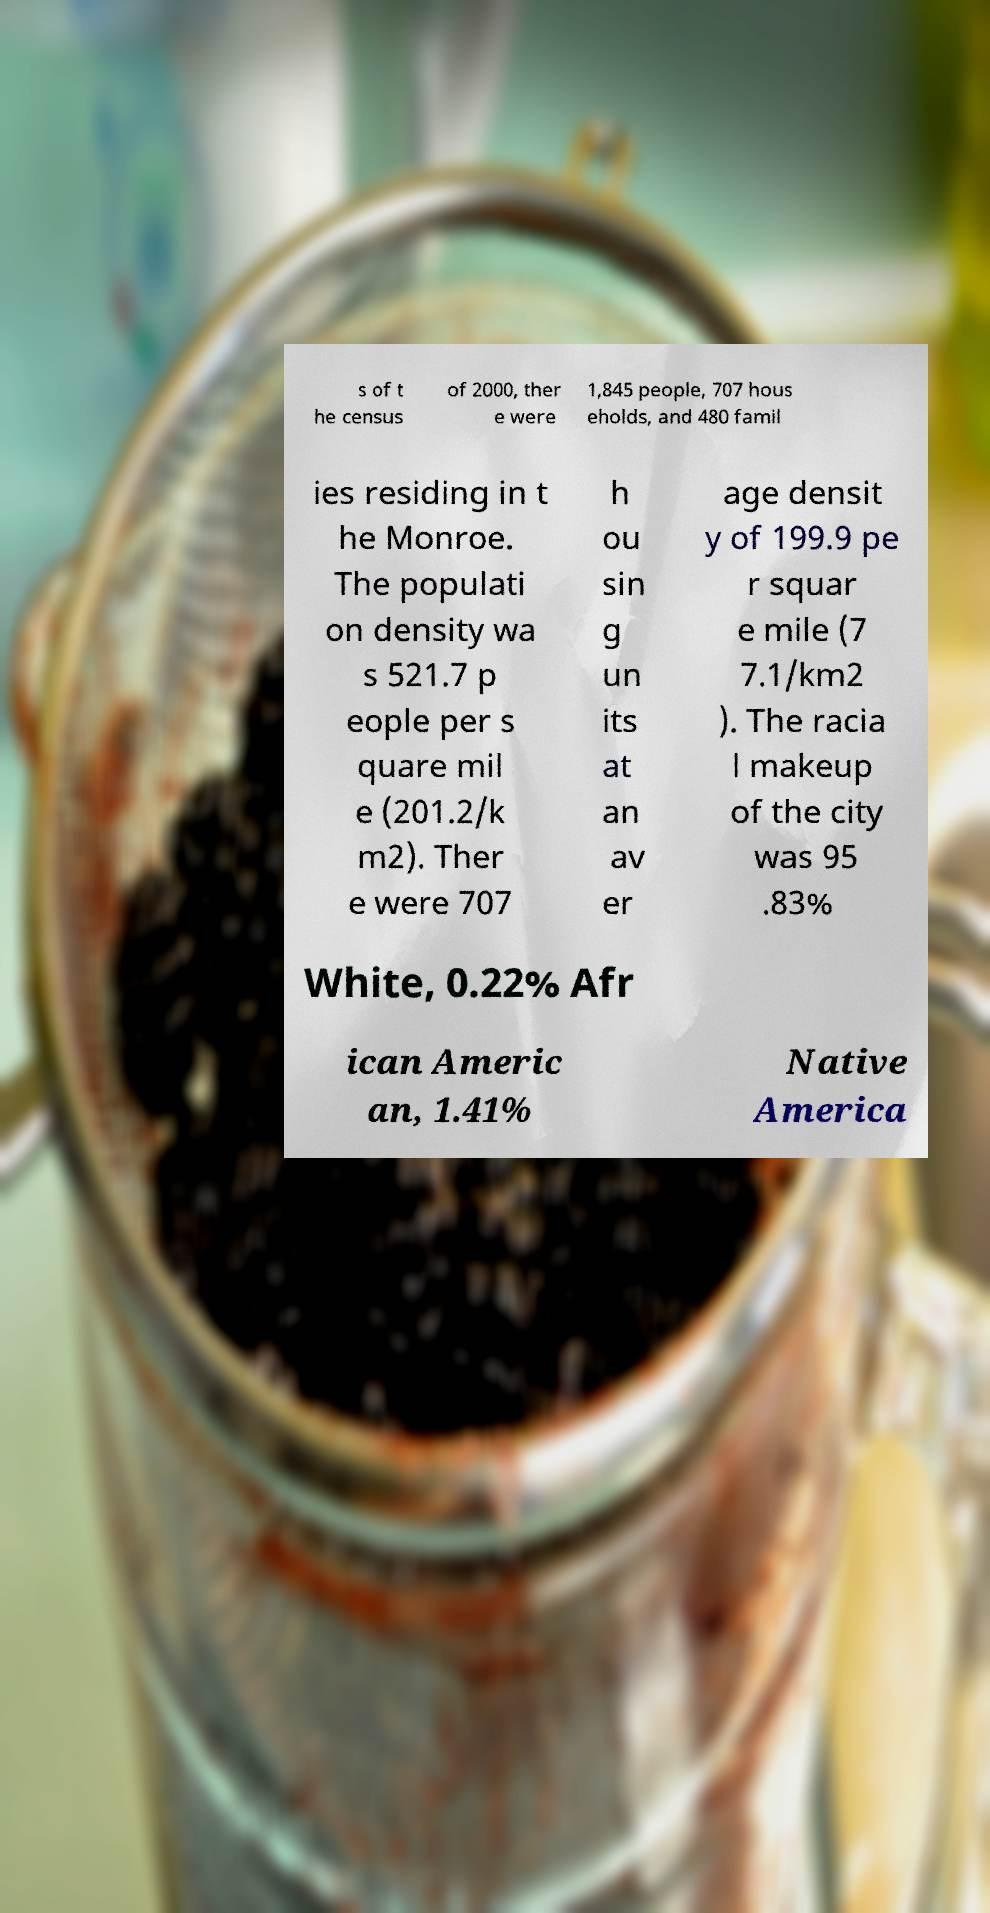For documentation purposes, I need the text within this image transcribed. Could you provide that? s of t he census of 2000, ther e were 1,845 people, 707 hous eholds, and 480 famil ies residing in t he Monroe. The populati on density wa s 521.7 p eople per s quare mil e (201.2/k m2). Ther e were 707 h ou sin g un its at an av er age densit y of 199.9 pe r squar e mile (7 7.1/km2 ). The racia l makeup of the city was 95 .83% White, 0.22% Afr ican Americ an, 1.41% Native America 